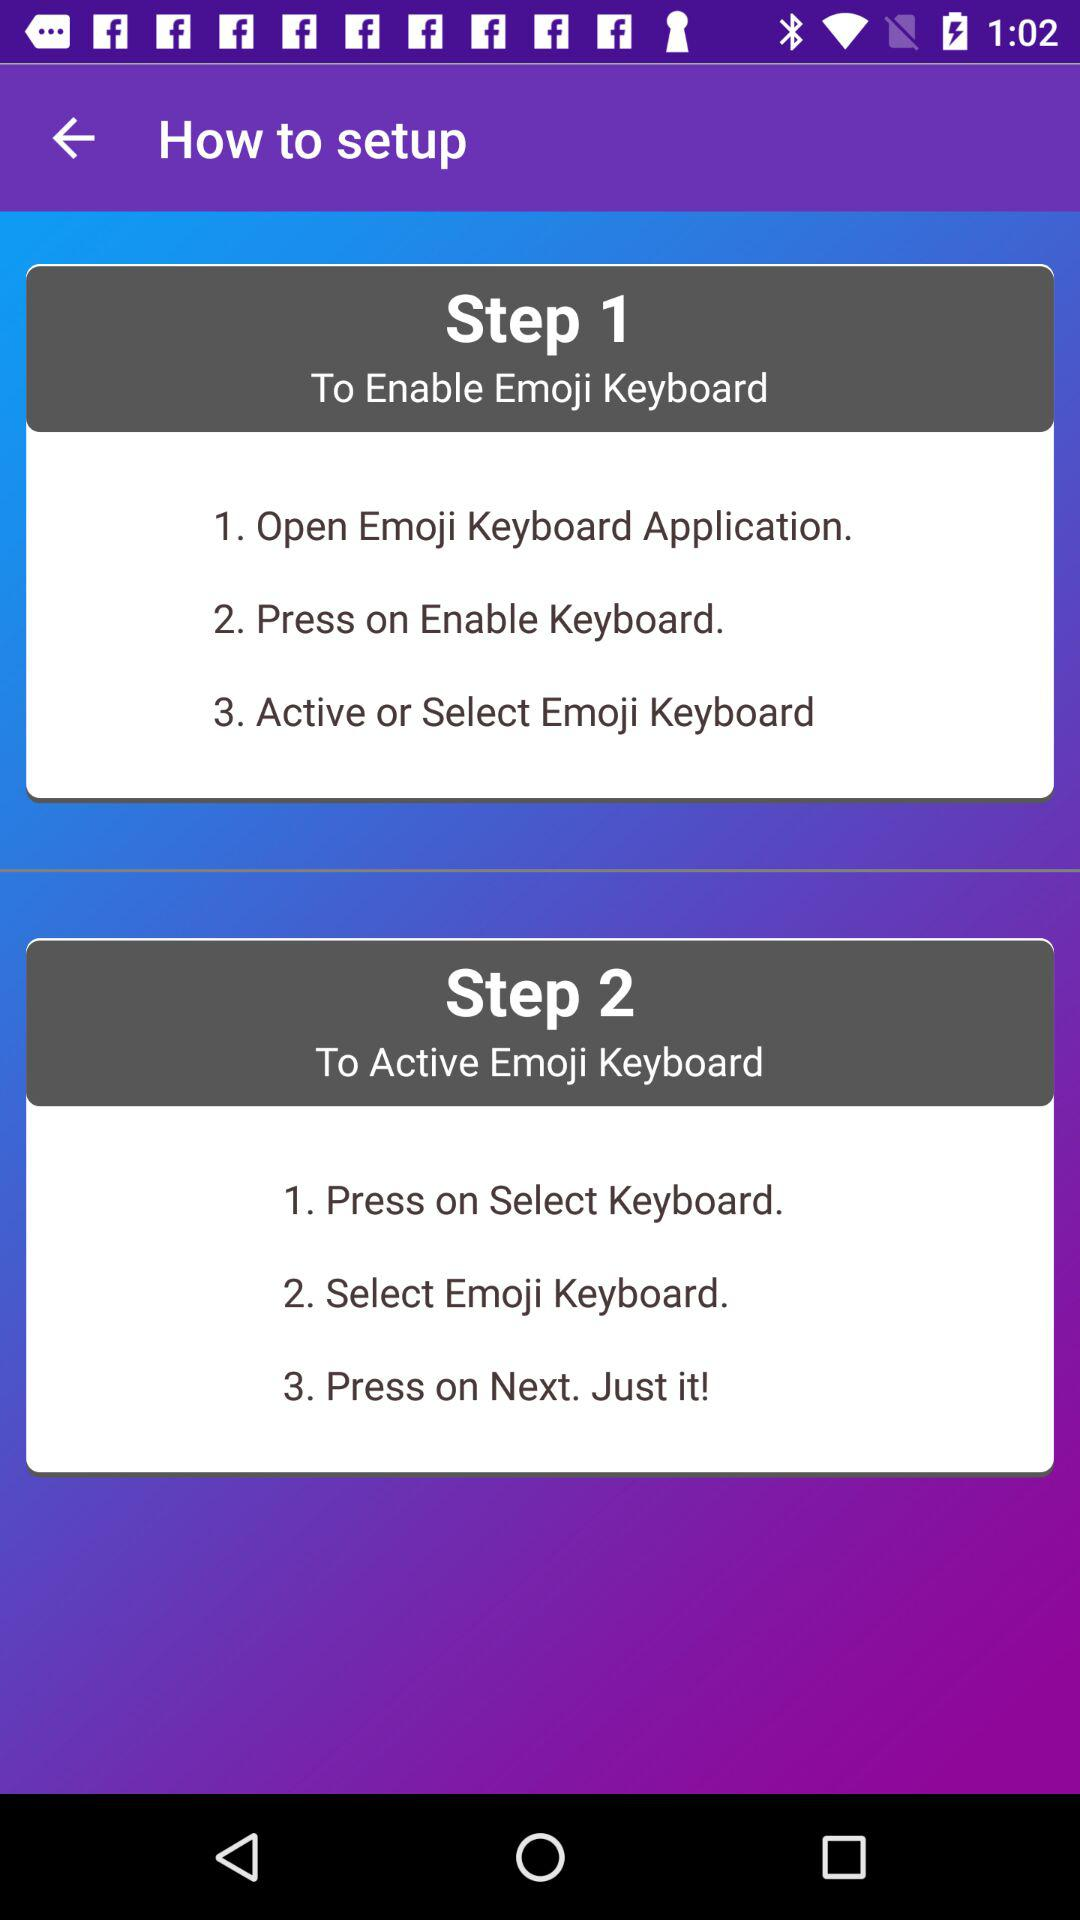What is the name of the user?
When the provided information is insufficient, respond with <no answer>. <no answer> 